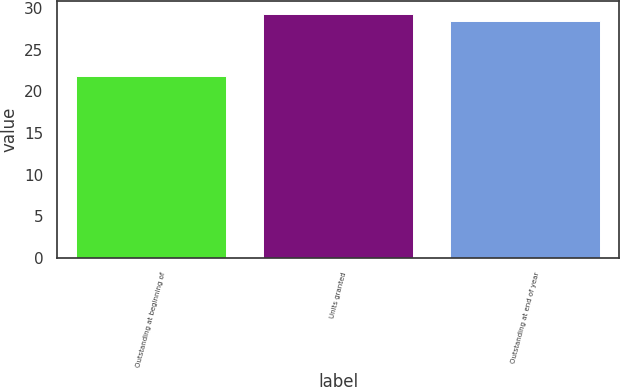Convert chart to OTSL. <chart><loc_0><loc_0><loc_500><loc_500><bar_chart><fcel>Outstanding at beginning of<fcel>Units granted<fcel>Outstanding at end of year<nl><fcel>21.84<fcel>29.35<fcel>28.47<nl></chart> 